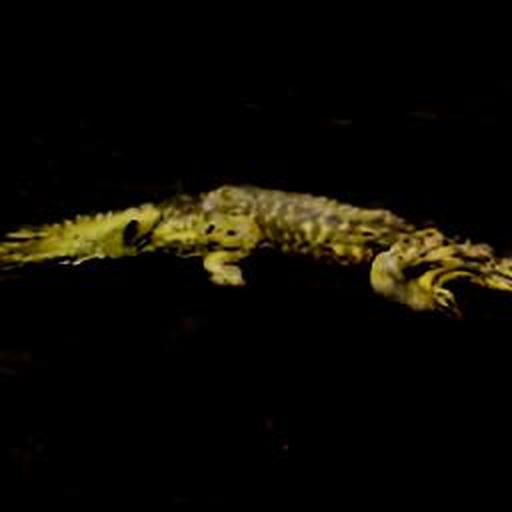Are there any quality issues with this image? Yes, the image appears to be quite dark, and the subject, which seems to be a crocodile, is not well-lit, resulting in a lack of detail and contrast. There may also be some blurriness, making it difficult to see finer features clearly. 